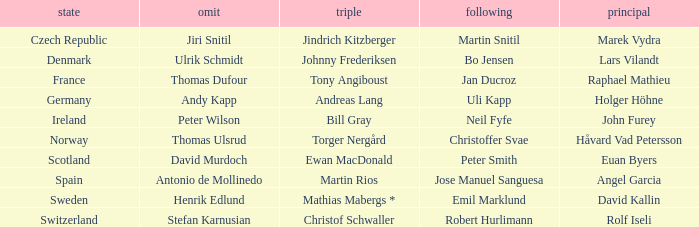Would you mind parsing the complete table? {'header': ['state', 'omit', 'triple', 'following', 'principal'], 'rows': [['Czech Republic', 'Jiri Snitil', 'Jindrich Kitzberger', 'Martin Snitil', 'Marek Vydra'], ['Denmark', 'Ulrik Schmidt', 'Johnny Frederiksen', 'Bo Jensen', 'Lars Vilandt'], ['France', 'Thomas Dufour', 'Tony Angiboust', 'Jan Ducroz', 'Raphael Mathieu'], ['Germany', 'Andy Kapp', 'Andreas Lang', 'Uli Kapp', 'Holger Höhne'], ['Ireland', 'Peter Wilson', 'Bill Gray', 'Neil Fyfe', 'John Furey'], ['Norway', 'Thomas Ulsrud', 'Torger Nergård', 'Christoffer Svae', 'Håvard Vad Petersson'], ['Scotland', 'David Murdoch', 'Ewan MacDonald', 'Peter Smith', 'Euan Byers'], ['Spain', 'Antonio de Mollinedo', 'Martin Rios', 'Jose Manuel Sanguesa', 'Angel Garcia'], ['Sweden', 'Henrik Edlund', 'Mathias Mabergs *', 'Emil Marklund', 'David Kallin'], ['Switzerland', 'Stefan Karnusian', 'Christof Schwaller', 'Robert Hurlimann', 'Rolf Iseli']]} When did France come in second? Jan Ducroz. 